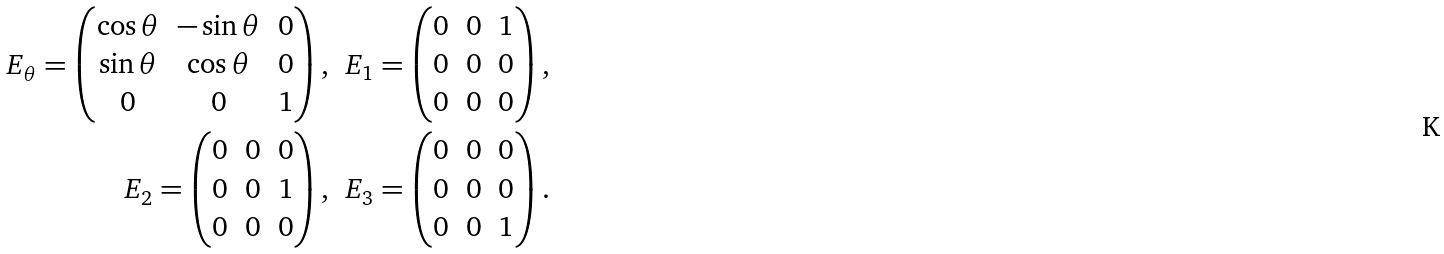<formula> <loc_0><loc_0><loc_500><loc_500>E _ { \theta } = \left ( \begin{matrix} \cos \theta & - \sin \theta & 0 \\ \sin \theta & \cos \theta & 0 \\ 0 & 0 & 1 \end{matrix} \right ) , \ \ & E _ { 1 } = \left ( \begin{matrix} 0 & 0 & 1 \\ 0 & 0 & 0 \\ 0 & 0 & 0 \end{matrix} \right ) , \\ E _ { 2 } = \left ( \begin{matrix} 0 & 0 & 0 \\ 0 & 0 & 1 \\ 0 & 0 & 0 \end{matrix} \right ) , \ \ & E _ { 3 } = \left ( \begin{matrix} 0 & 0 & 0 \\ 0 & 0 & 0 \\ 0 & 0 & 1 \end{matrix} \right ) .</formula> 